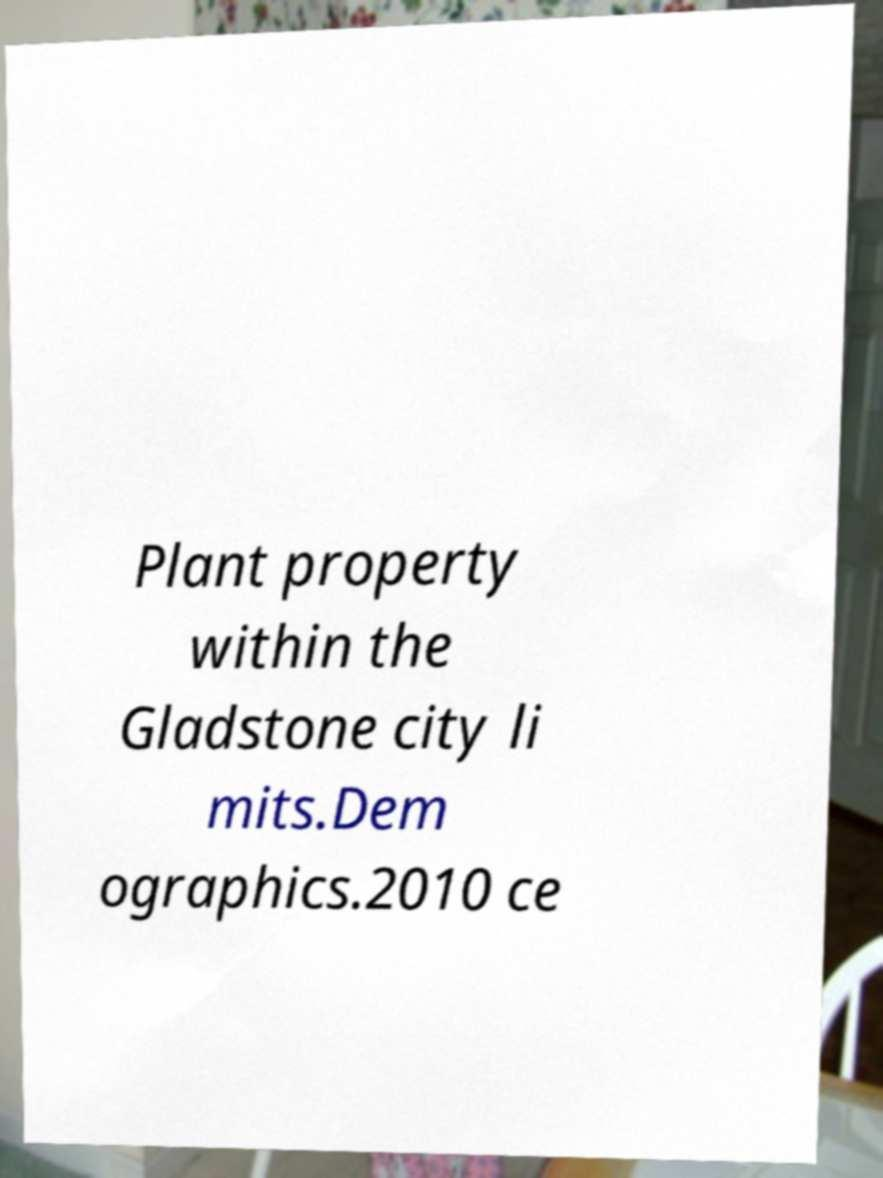I need the written content from this picture converted into text. Can you do that? Plant property within the Gladstone city li mits.Dem ographics.2010 ce 